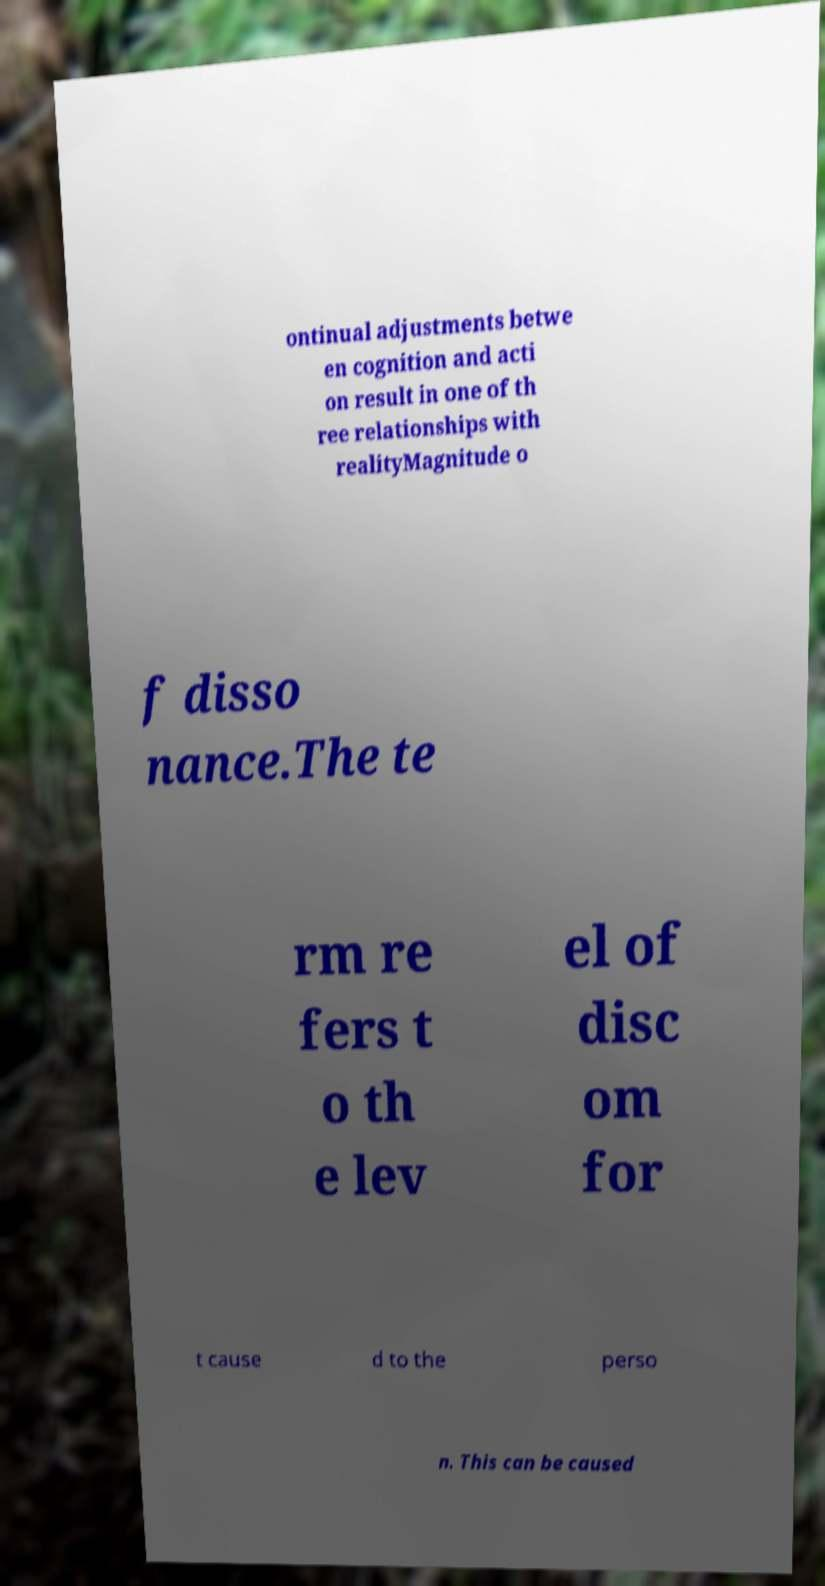Could you assist in decoding the text presented in this image and type it out clearly? ontinual adjustments betwe en cognition and acti on result in one of th ree relationships with realityMagnitude o f disso nance.The te rm re fers t o th e lev el of disc om for t cause d to the perso n. This can be caused 